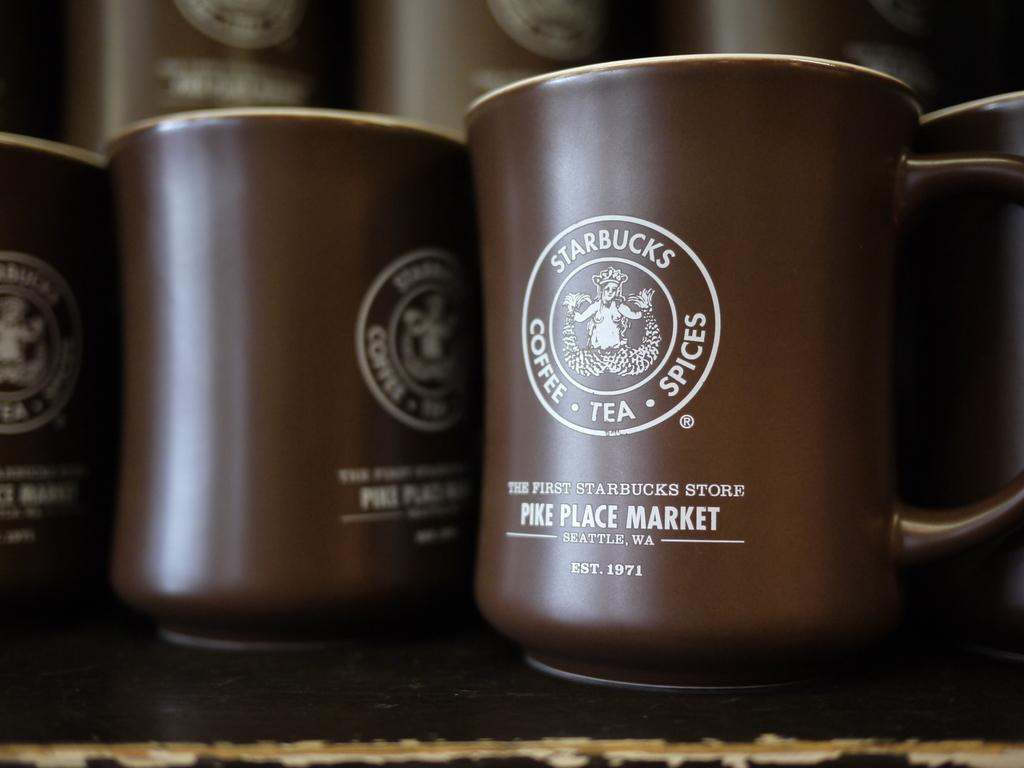Provide a one-sentence caption for the provided image. A brown Starbucks mug from Pike Place Market. 